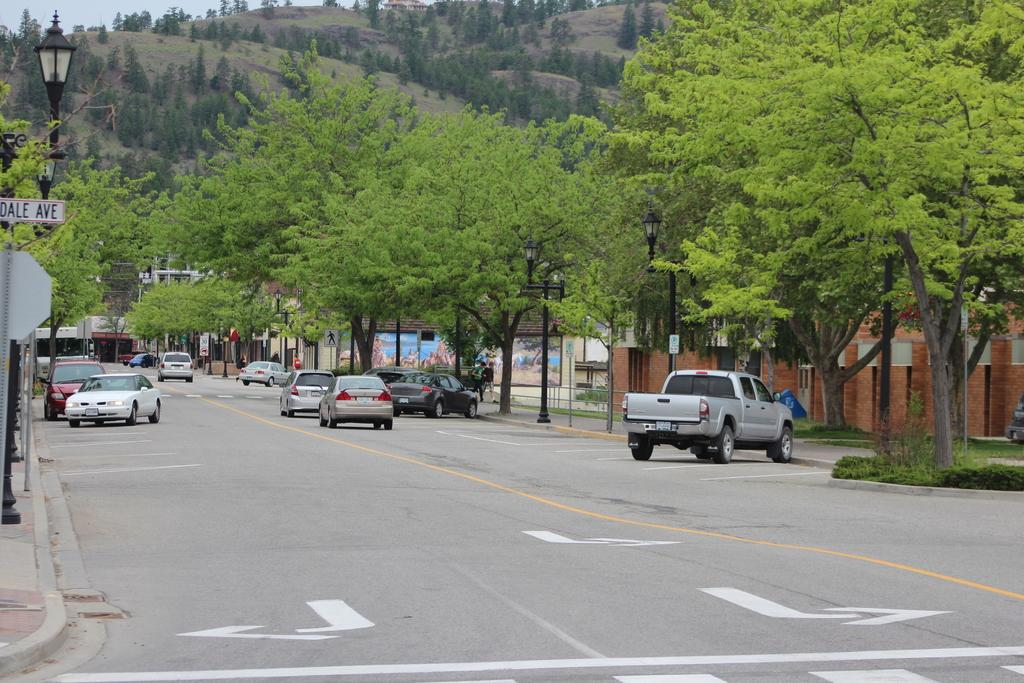What types of objects can be seen in the image? There are vehicles, buildings, street lamps, sign poles, and trees visible in the image. What type of terrain is visible in the image? Hills are visible in the image. What is the ground surface like in the image? There is grass visible in the image. What color is the sock on the tree in the image? There is no sock present in the image; it is not an object that can be found in the provided facts. 